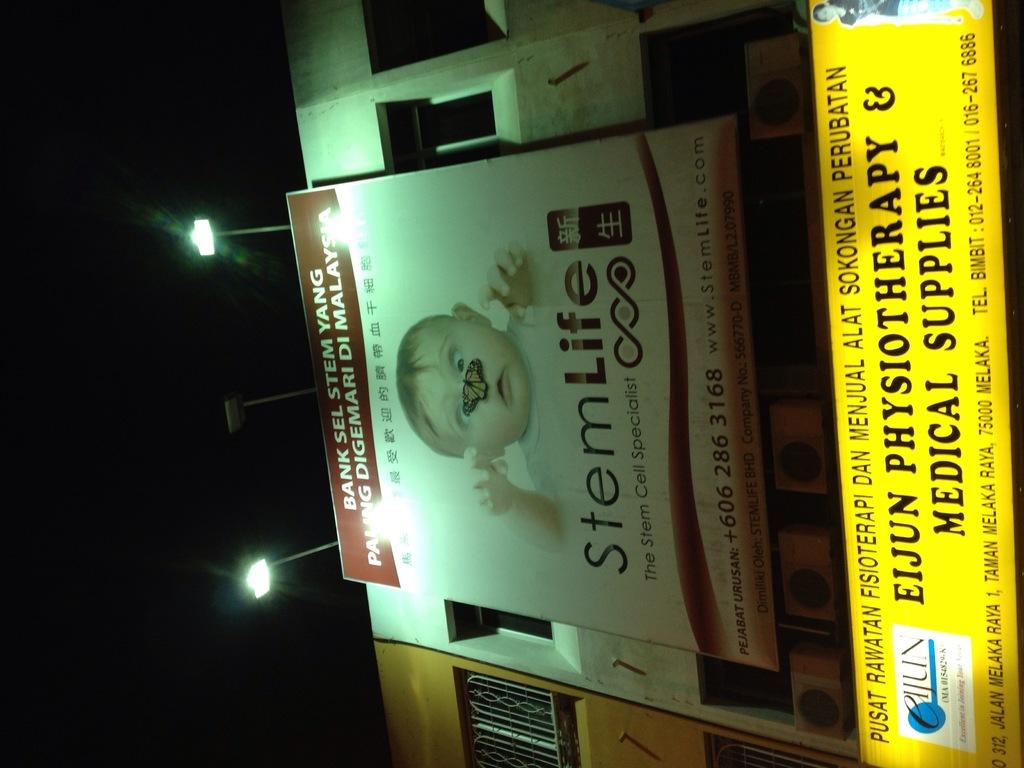What is the name of this product?
Offer a terse response. Stemlife. What is the phone number on the box?
Offer a terse response. 6062863168. 